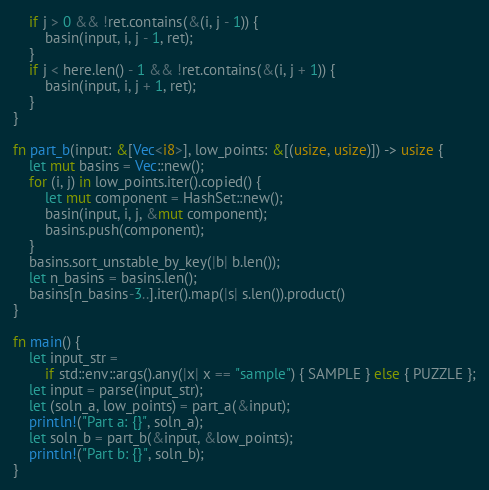<code> <loc_0><loc_0><loc_500><loc_500><_Rust_>    if j > 0 && !ret.contains(&(i, j - 1)) {
        basin(input, i, j - 1, ret);
    }
    if j < here.len() - 1 && !ret.contains(&(i, j + 1)) {
        basin(input, i, j + 1, ret);
    }
}

fn part_b(input: &[Vec<i8>], low_points: &[(usize, usize)]) -> usize {
    let mut basins = Vec::new();
    for (i, j) in low_points.iter().copied() {
        let mut component = HashSet::new();
        basin(input, i, j, &mut component);
        basins.push(component);
    }
    basins.sort_unstable_by_key(|b| b.len());
    let n_basins = basins.len();
    basins[n_basins-3..].iter().map(|s| s.len()).product()
}

fn main() {
    let input_str =
        if std::env::args().any(|x| x == "sample") { SAMPLE } else { PUZZLE };
    let input = parse(input_str);
    let (soln_a, low_points) = part_a(&input);
    println!("Part a: {}", soln_a);
    let soln_b = part_b(&input, &low_points);
    println!("Part b: {}", soln_b);
}
</code> 